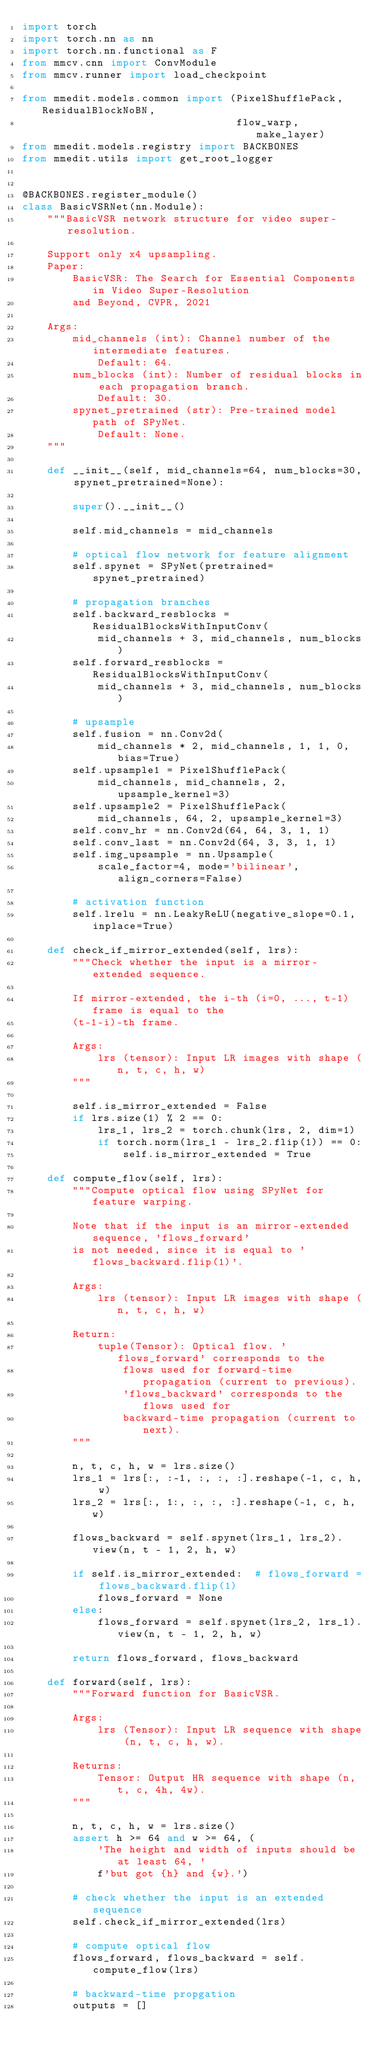Convert code to text. <code><loc_0><loc_0><loc_500><loc_500><_Python_>import torch
import torch.nn as nn
import torch.nn.functional as F
from mmcv.cnn import ConvModule
from mmcv.runner import load_checkpoint

from mmedit.models.common import (PixelShufflePack, ResidualBlockNoBN,
                                  flow_warp, make_layer)
from mmedit.models.registry import BACKBONES
from mmedit.utils import get_root_logger


@BACKBONES.register_module()
class BasicVSRNet(nn.Module):
    """BasicVSR network structure for video super-resolution.

    Support only x4 upsampling.
    Paper:
        BasicVSR: The Search for Essential Components in Video Super-Resolution
        and Beyond, CVPR, 2021

    Args:
        mid_channels (int): Channel number of the intermediate features.
            Default: 64.
        num_blocks (int): Number of residual blocks in each propagation branch.
            Default: 30.
        spynet_pretrained (str): Pre-trained model path of SPyNet.
            Default: None.
    """

    def __init__(self, mid_channels=64, num_blocks=30, spynet_pretrained=None):

        super().__init__()

        self.mid_channels = mid_channels

        # optical flow network for feature alignment
        self.spynet = SPyNet(pretrained=spynet_pretrained)

        # propagation branches
        self.backward_resblocks = ResidualBlocksWithInputConv(
            mid_channels + 3, mid_channels, num_blocks)
        self.forward_resblocks = ResidualBlocksWithInputConv(
            mid_channels + 3, mid_channels, num_blocks)

        # upsample
        self.fusion = nn.Conv2d(
            mid_channels * 2, mid_channels, 1, 1, 0, bias=True)
        self.upsample1 = PixelShufflePack(
            mid_channels, mid_channels, 2, upsample_kernel=3)
        self.upsample2 = PixelShufflePack(
            mid_channels, 64, 2, upsample_kernel=3)
        self.conv_hr = nn.Conv2d(64, 64, 3, 1, 1)
        self.conv_last = nn.Conv2d(64, 3, 3, 1, 1)
        self.img_upsample = nn.Upsample(
            scale_factor=4, mode='bilinear', align_corners=False)

        # activation function
        self.lrelu = nn.LeakyReLU(negative_slope=0.1, inplace=True)

    def check_if_mirror_extended(self, lrs):
        """Check whether the input is a mirror-extended sequence.

        If mirror-extended, the i-th (i=0, ..., t-1) frame is equal to the
        (t-1-i)-th frame.

        Args:
            lrs (tensor): Input LR images with shape (n, t, c, h, w)
        """

        self.is_mirror_extended = False
        if lrs.size(1) % 2 == 0:
            lrs_1, lrs_2 = torch.chunk(lrs, 2, dim=1)
            if torch.norm(lrs_1 - lrs_2.flip(1)) == 0:
                self.is_mirror_extended = True

    def compute_flow(self, lrs):
        """Compute optical flow using SPyNet for feature warping.

        Note that if the input is an mirror-extended sequence, 'flows_forward'
        is not needed, since it is equal to 'flows_backward.flip(1)'.

        Args:
            lrs (tensor): Input LR images with shape (n, t, c, h, w)

        Return:
            tuple(Tensor): Optical flow. 'flows_forward' corresponds to the
                flows used for forward-time propagation (current to previous).
                'flows_backward' corresponds to the flows used for
                backward-time propagation (current to next).
        """

        n, t, c, h, w = lrs.size()
        lrs_1 = lrs[:, :-1, :, :, :].reshape(-1, c, h, w)
        lrs_2 = lrs[:, 1:, :, :, :].reshape(-1, c, h, w)

        flows_backward = self.spynet(lrs_1, lrs_2).view(n, t - 1, 2, h, w)

        if self.is_mirror_extended:  # flows_forward = flows_backward.flip(1)
            flows_forward = None
        else:
            flows_forward = self.spynet(lrs_2, lrs_1).view(n, t - 1, 2, h, w)

        return flows_forward, flows_backward

    def forward(self, lrs):
        """Forward function for BasicVSR.

        Args:
            lrs (Tensor): Input LR sequence with shape (n, t, c, h, w).

        Returns:
            Tensor: Output HR sequence with shape (n, t, c, 4h, 4w).
        """

        n, t, c, h, w = lrs.size()
        assert h >= 64 and w >= 64, (
            'The height and width of inputs should be at least 64, '
            f'but got {h} and {w}.')

        # check whether the input is an extended sequence
        self.check_if_mirror_extended(lrs)

        # compute optical flow
        flows_forward, flows_backward = self.compute_flow(lrs)

        # backward-time propgation
        outputs = []</code> 